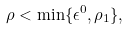<formula> <loc_0><loc_0><loc_500><loc_500>\rho < \min \{ \epsilon ^ { 0 } , \rho _ { 1 } \} ,</formula> 